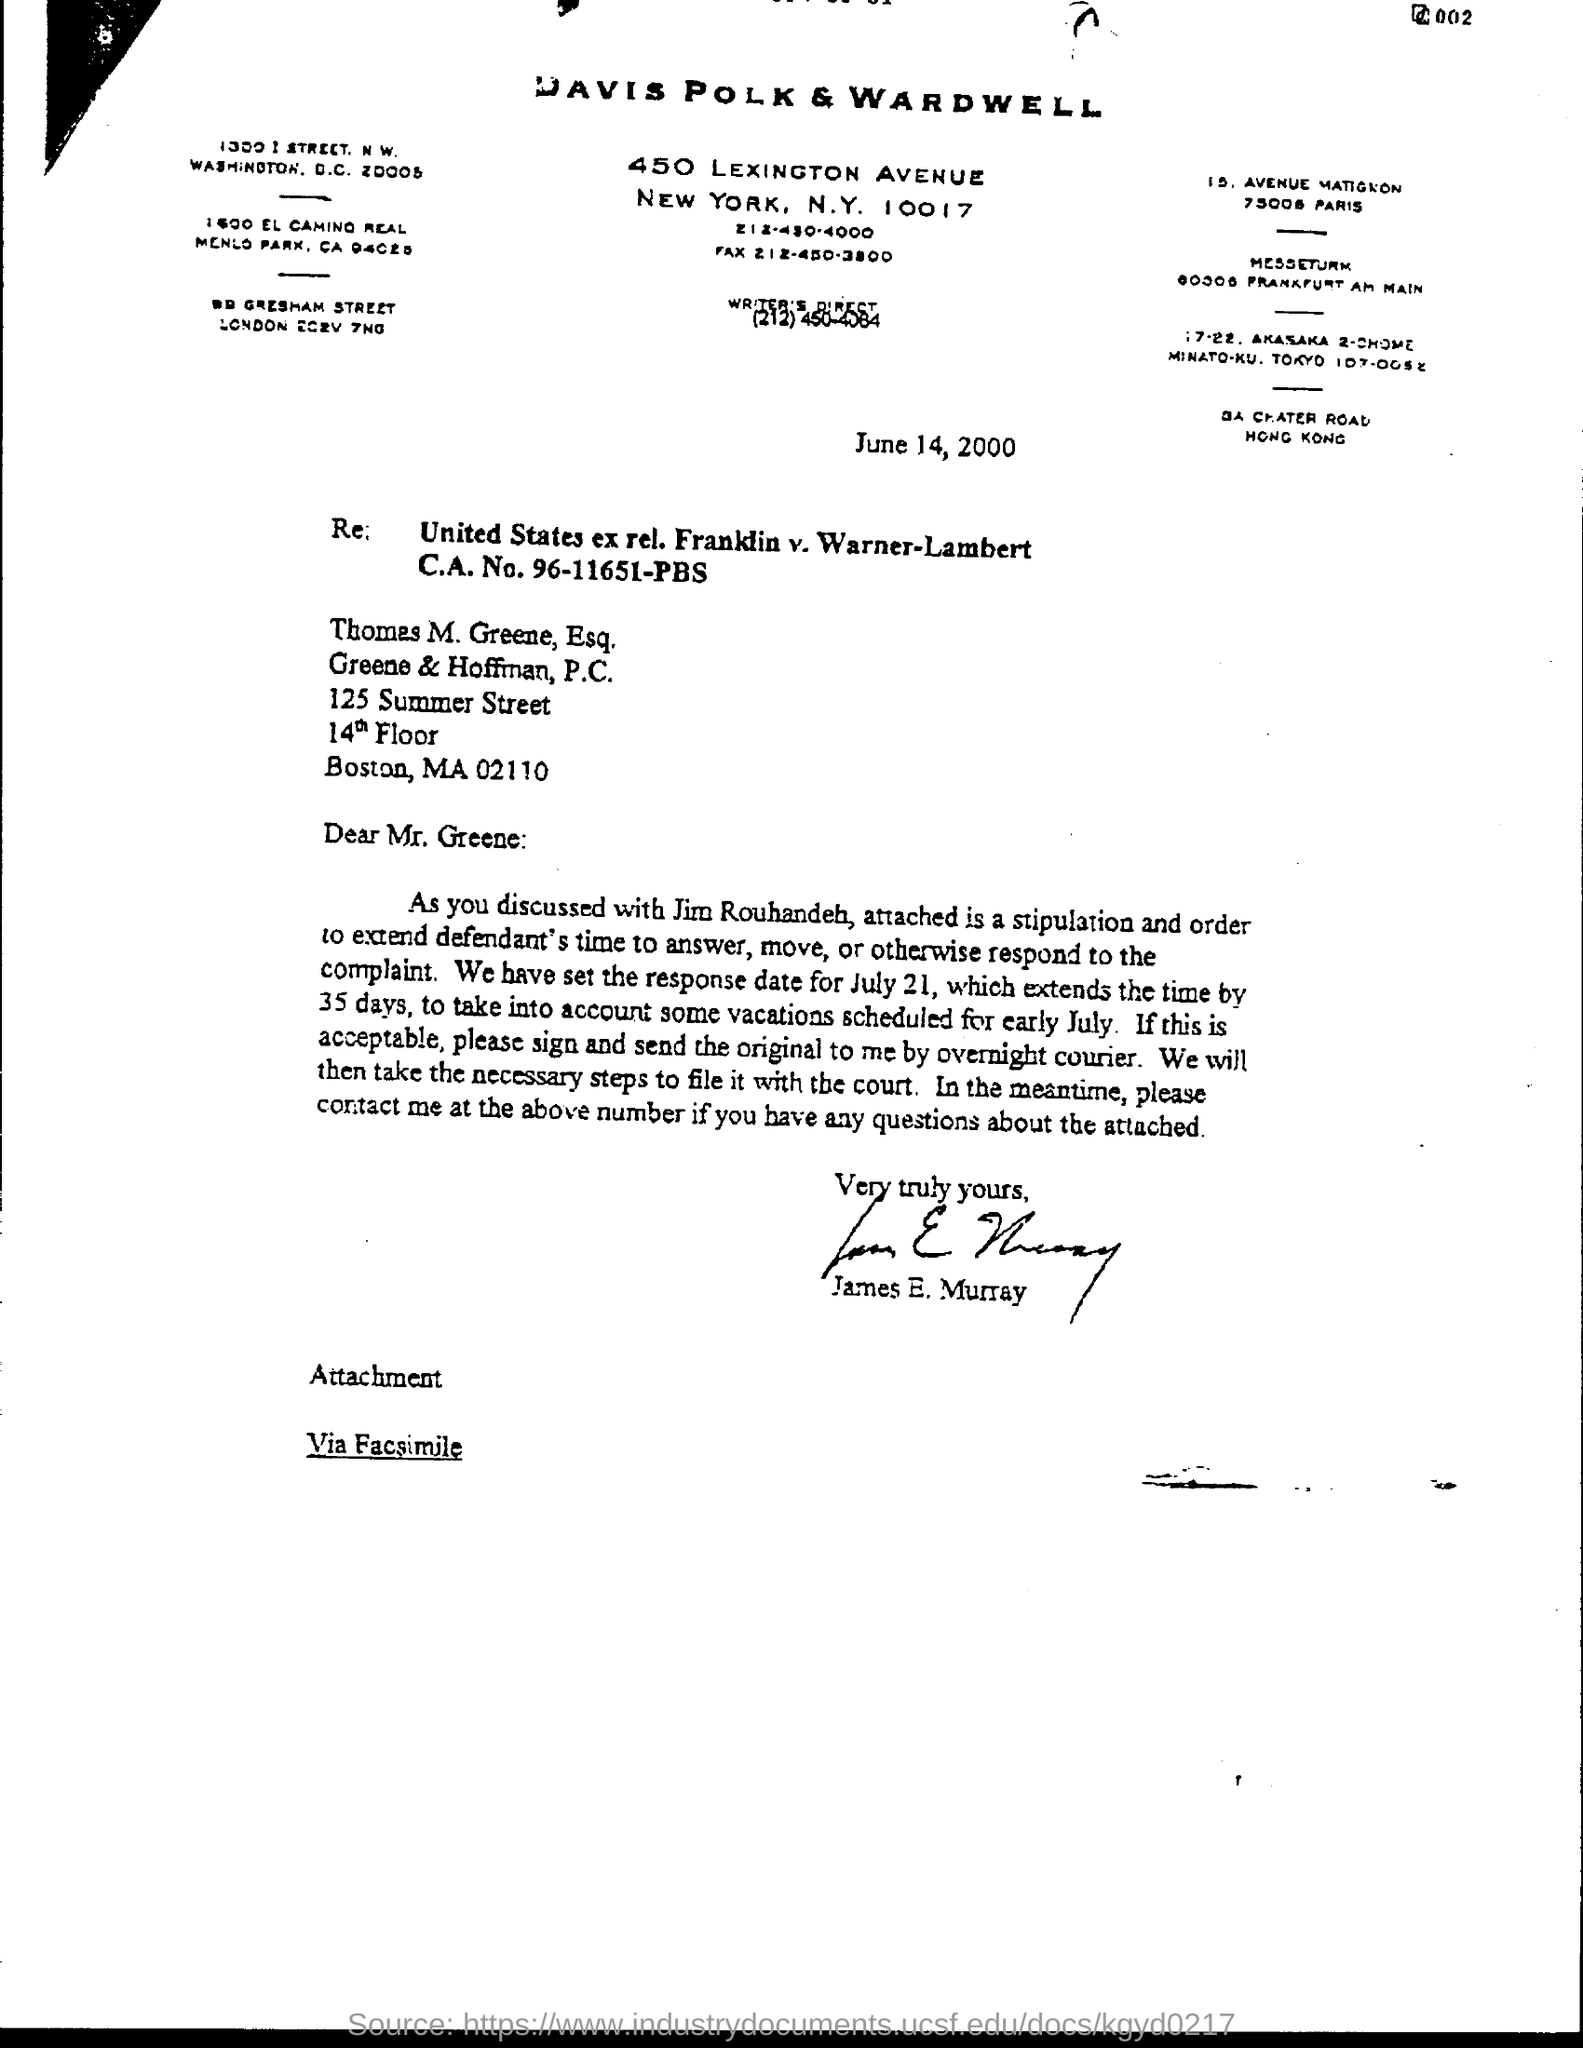To whom is this letter written to?
Keep it short and to the point. Thomas M. Greene, Esq. Who wrote this letter?
Keep it short and to the point. James E. Murray. 